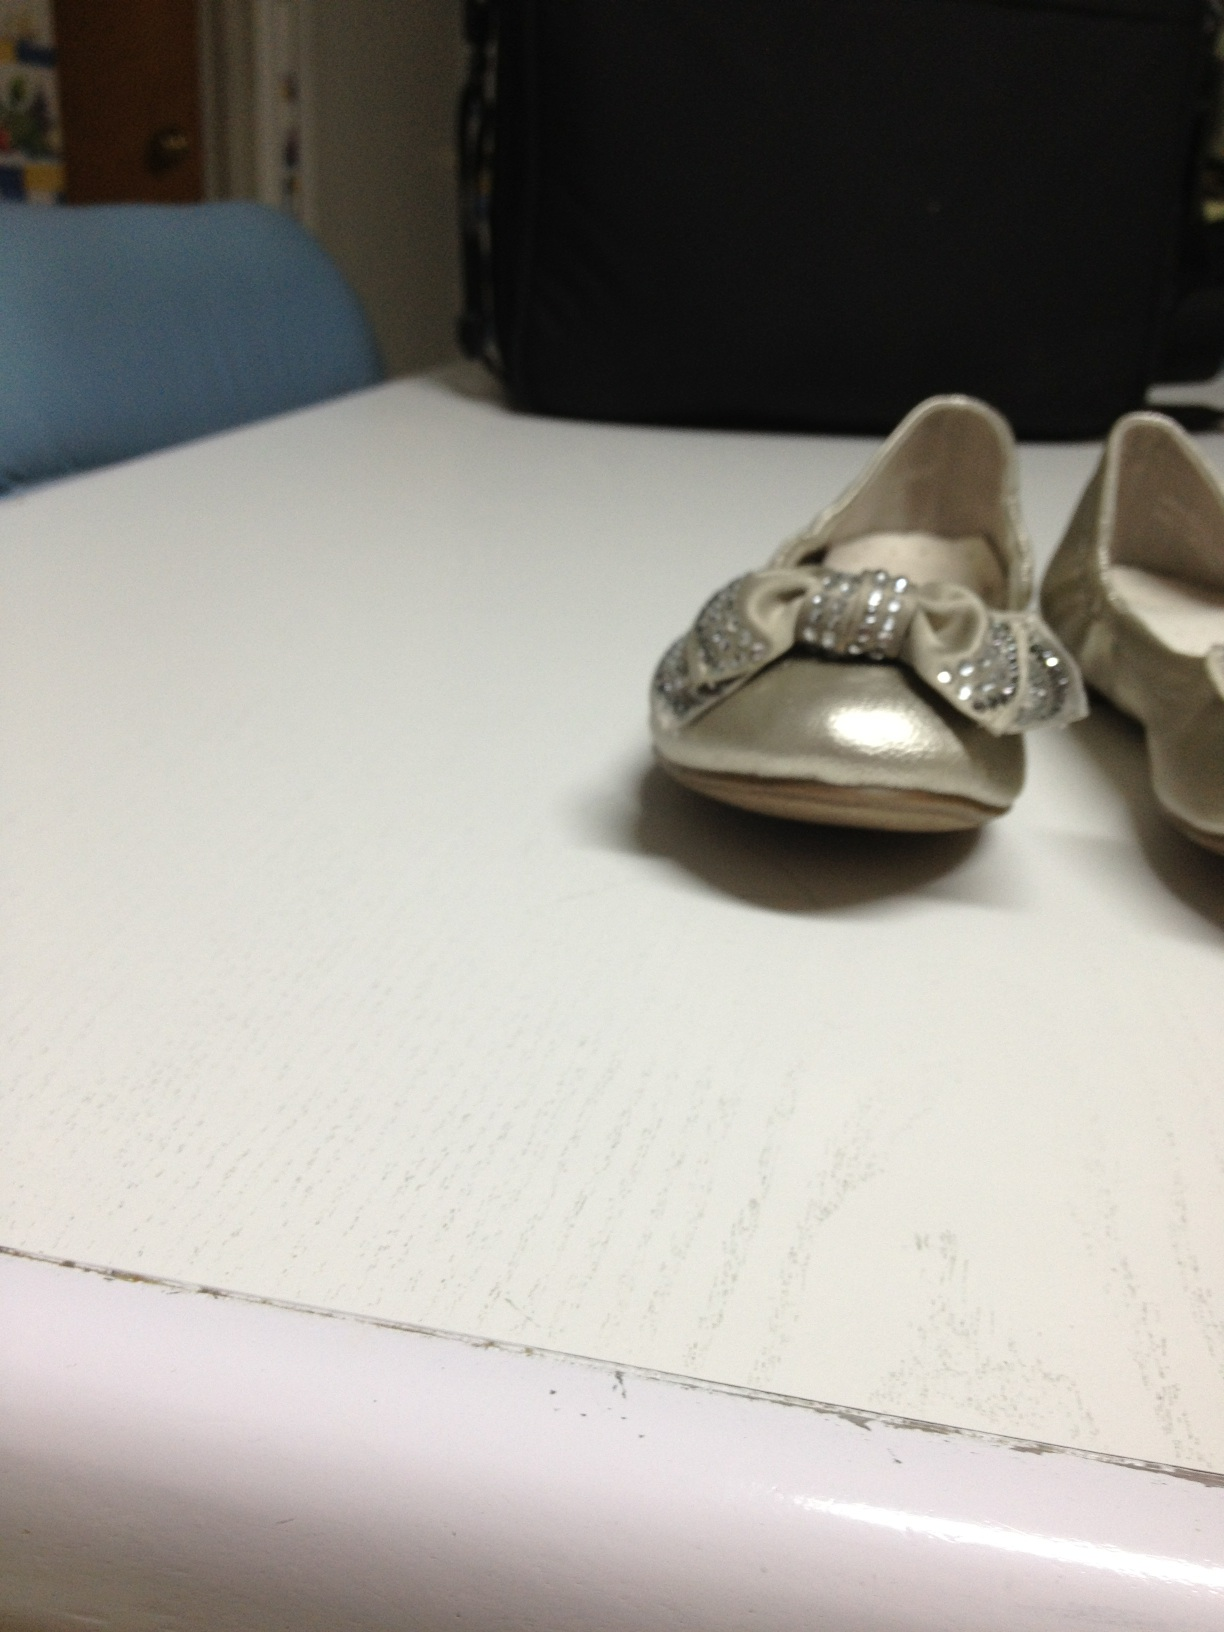Can you describe what these shoes might be used for? These shoes appear to be designed for a child, possibly for a special event such as a wedding, birthday party, or holiday celebration. Their elegant design with sparkling bows suggests they are meant for occasions where a touch of formality and festivity is desired. 